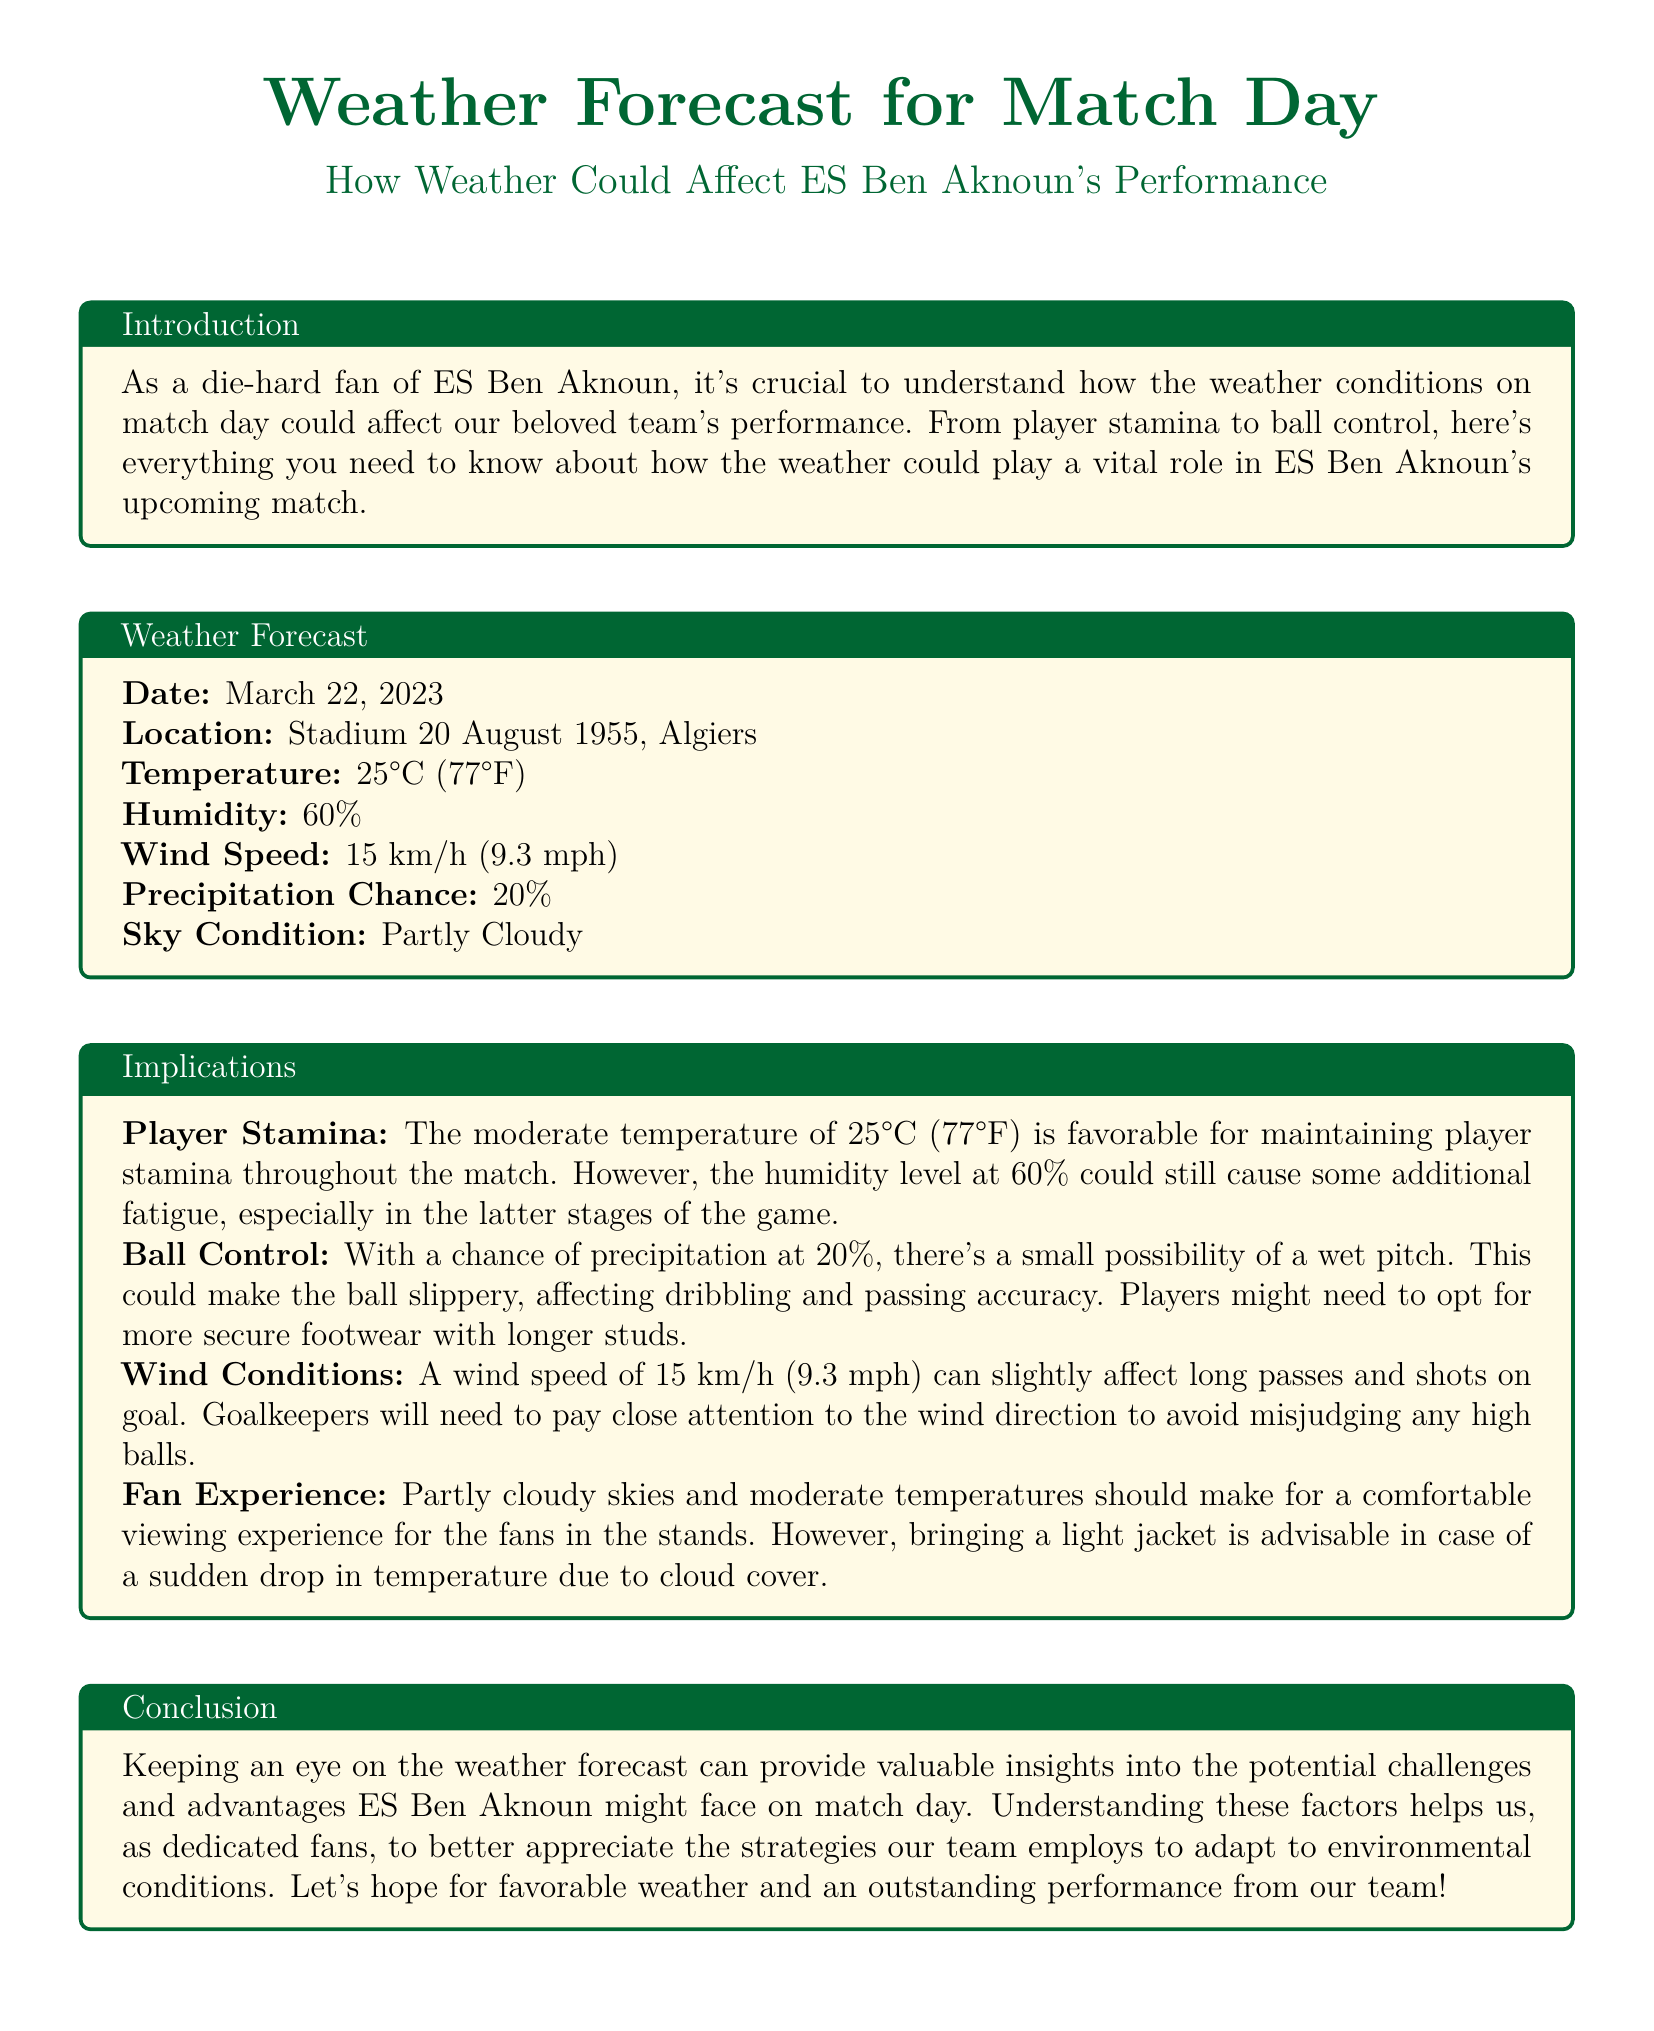What is the match date? The match date is mentioned in the weather forecast section of the document, which is March 22, 2023.
Answer: March 22, 2023 What is the location of the match? The location is specified as Stadium 20 August 1955, Algiers in the weather forecast section.
Answer: Stadium 20 August 1955, Algiers What is the temperature on match day? The forecast states the temperature will be 25°C (77°F) on match day.
Answer: 25°C (77°F) What is the chance of precipitation? The document indicates a 20% chance of precipitation on match day.
Answer: 20% What wind speed is expected? The expected wind speed on match day is noted as 15 km/h (9.3 mph).
Answer: 15 km/h (9.3 mph) How does humidity affect player stamina? The document mentions that a humidity level of 60% could cause additional fatigue, especially in the latter stages of the game.
Answer: Additional fatigue What footwear may players need? The forecast suggests players might need to opt for more secure footwear with longer studs if there's a wet pitch.
Answer: Longer studs How will wind conditions affect goalkeepers? The document states that wind conditions may cause goalkeepers to misjudge high balls.
Answer: Misjudge high balls What is the sky condition on match day? The weather report notes that the sky will be partly cloudy on match day.
Answer: Partly Cloudy 